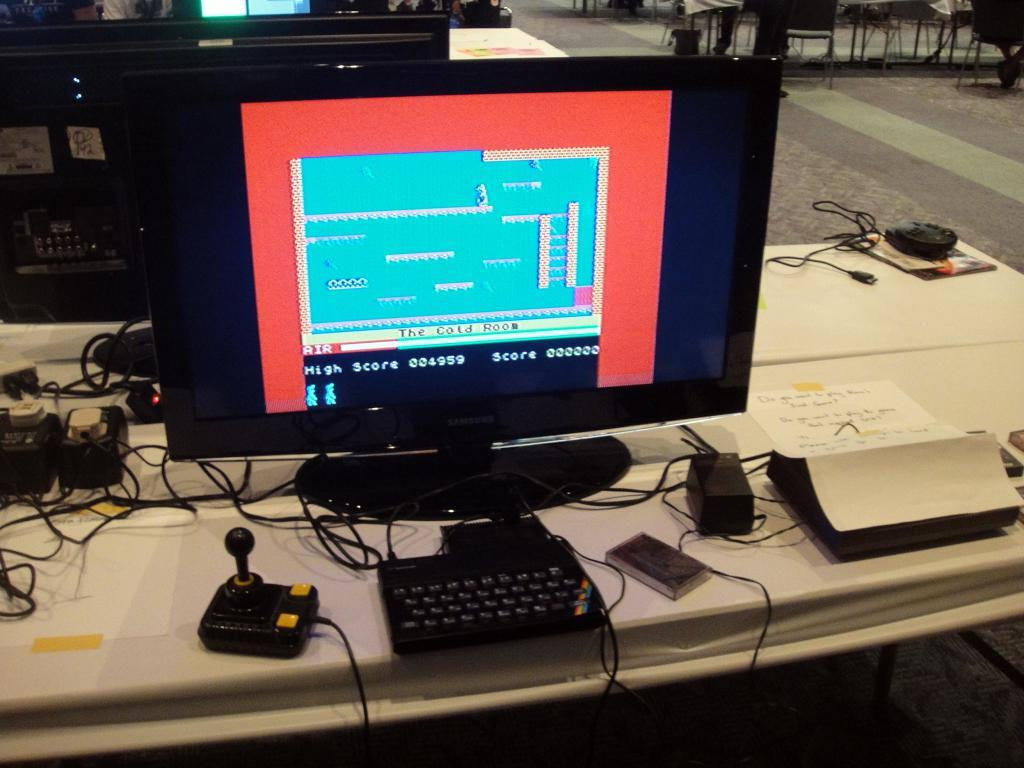<image>
Relay a brief, clear account of the picture shown. A game is displayed on a computer screen with a high score of 004959. 